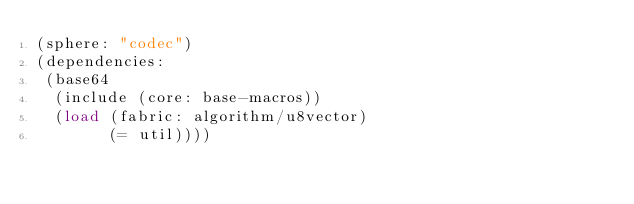<code> <loc_0><loc_0><loc_500><loc_500><_Scheme_>(sphere: "codec")
(dependencies:
 (base64
  (include (core: base-macros))
  (load (fabric: algorithm/u8vector)
        (= util))))
</code> 